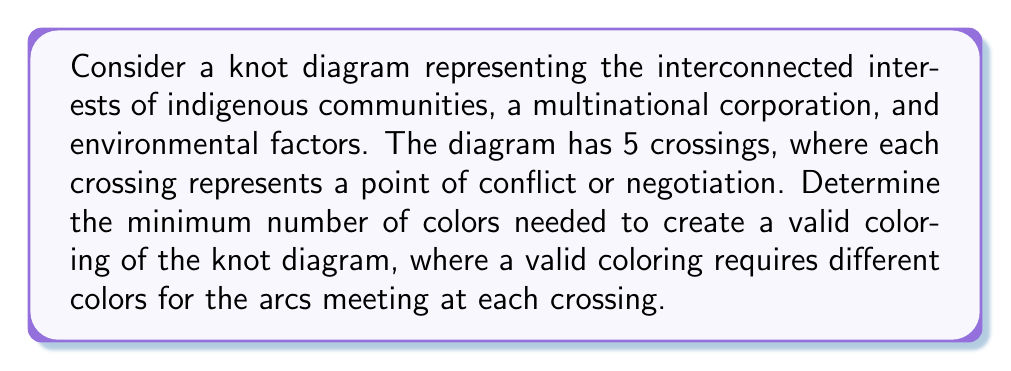Help me with this question. To determine the colorability of the knot diagram, we'll follow these steps:

1) First, recall the fundamental theorem of knot coloring: The minimum number of colors needed to color a knot diagram is always a power of 2 (i.e., 2, 4, 8, 16, etc.).

2) Next, we'll use the concept of the determinant of a knot. The determinant is related to the number of colorings a knot has. For a knot with n crossings, we can construct an (n-1) x (n-1) matrix M, where:
   - Diagonal entries are 2
   - Off-diagonal entries are -1 if the strands are connected, 0 otherwise

3) For our 5-crossing knot, we'll have a 4x4 matrix. Without knowing the exact configuration, let's assume a general case:

   $$M = \begin{pmatrix}
   2 & -1 & -1 & 0 \\
   -1 & 2 & 0 & -1 \\
   -1 & 0 & 2 & -1 \\
   0 & -1 & -1 & 2
   \end{pmatrix}$$

4) The determinant of this matrix gives us information about the colorability:
   
   $$\det(M) = 5$$

5) The number of colors needed is the greatest common divisor of the determinant and 2 (since we're working in mod 2 arithmetic for coloring):

   $$\gcd(\det(M), 2) = \gcd(5, 2) = 1$$

6) Since the GCD is 1, which is not a power of 2, we need the next power of 2, which is 2.

Therefore, the minimum number of colors needed for a valid coloring of this knot diagram is 2.
Answer: 2 colors 